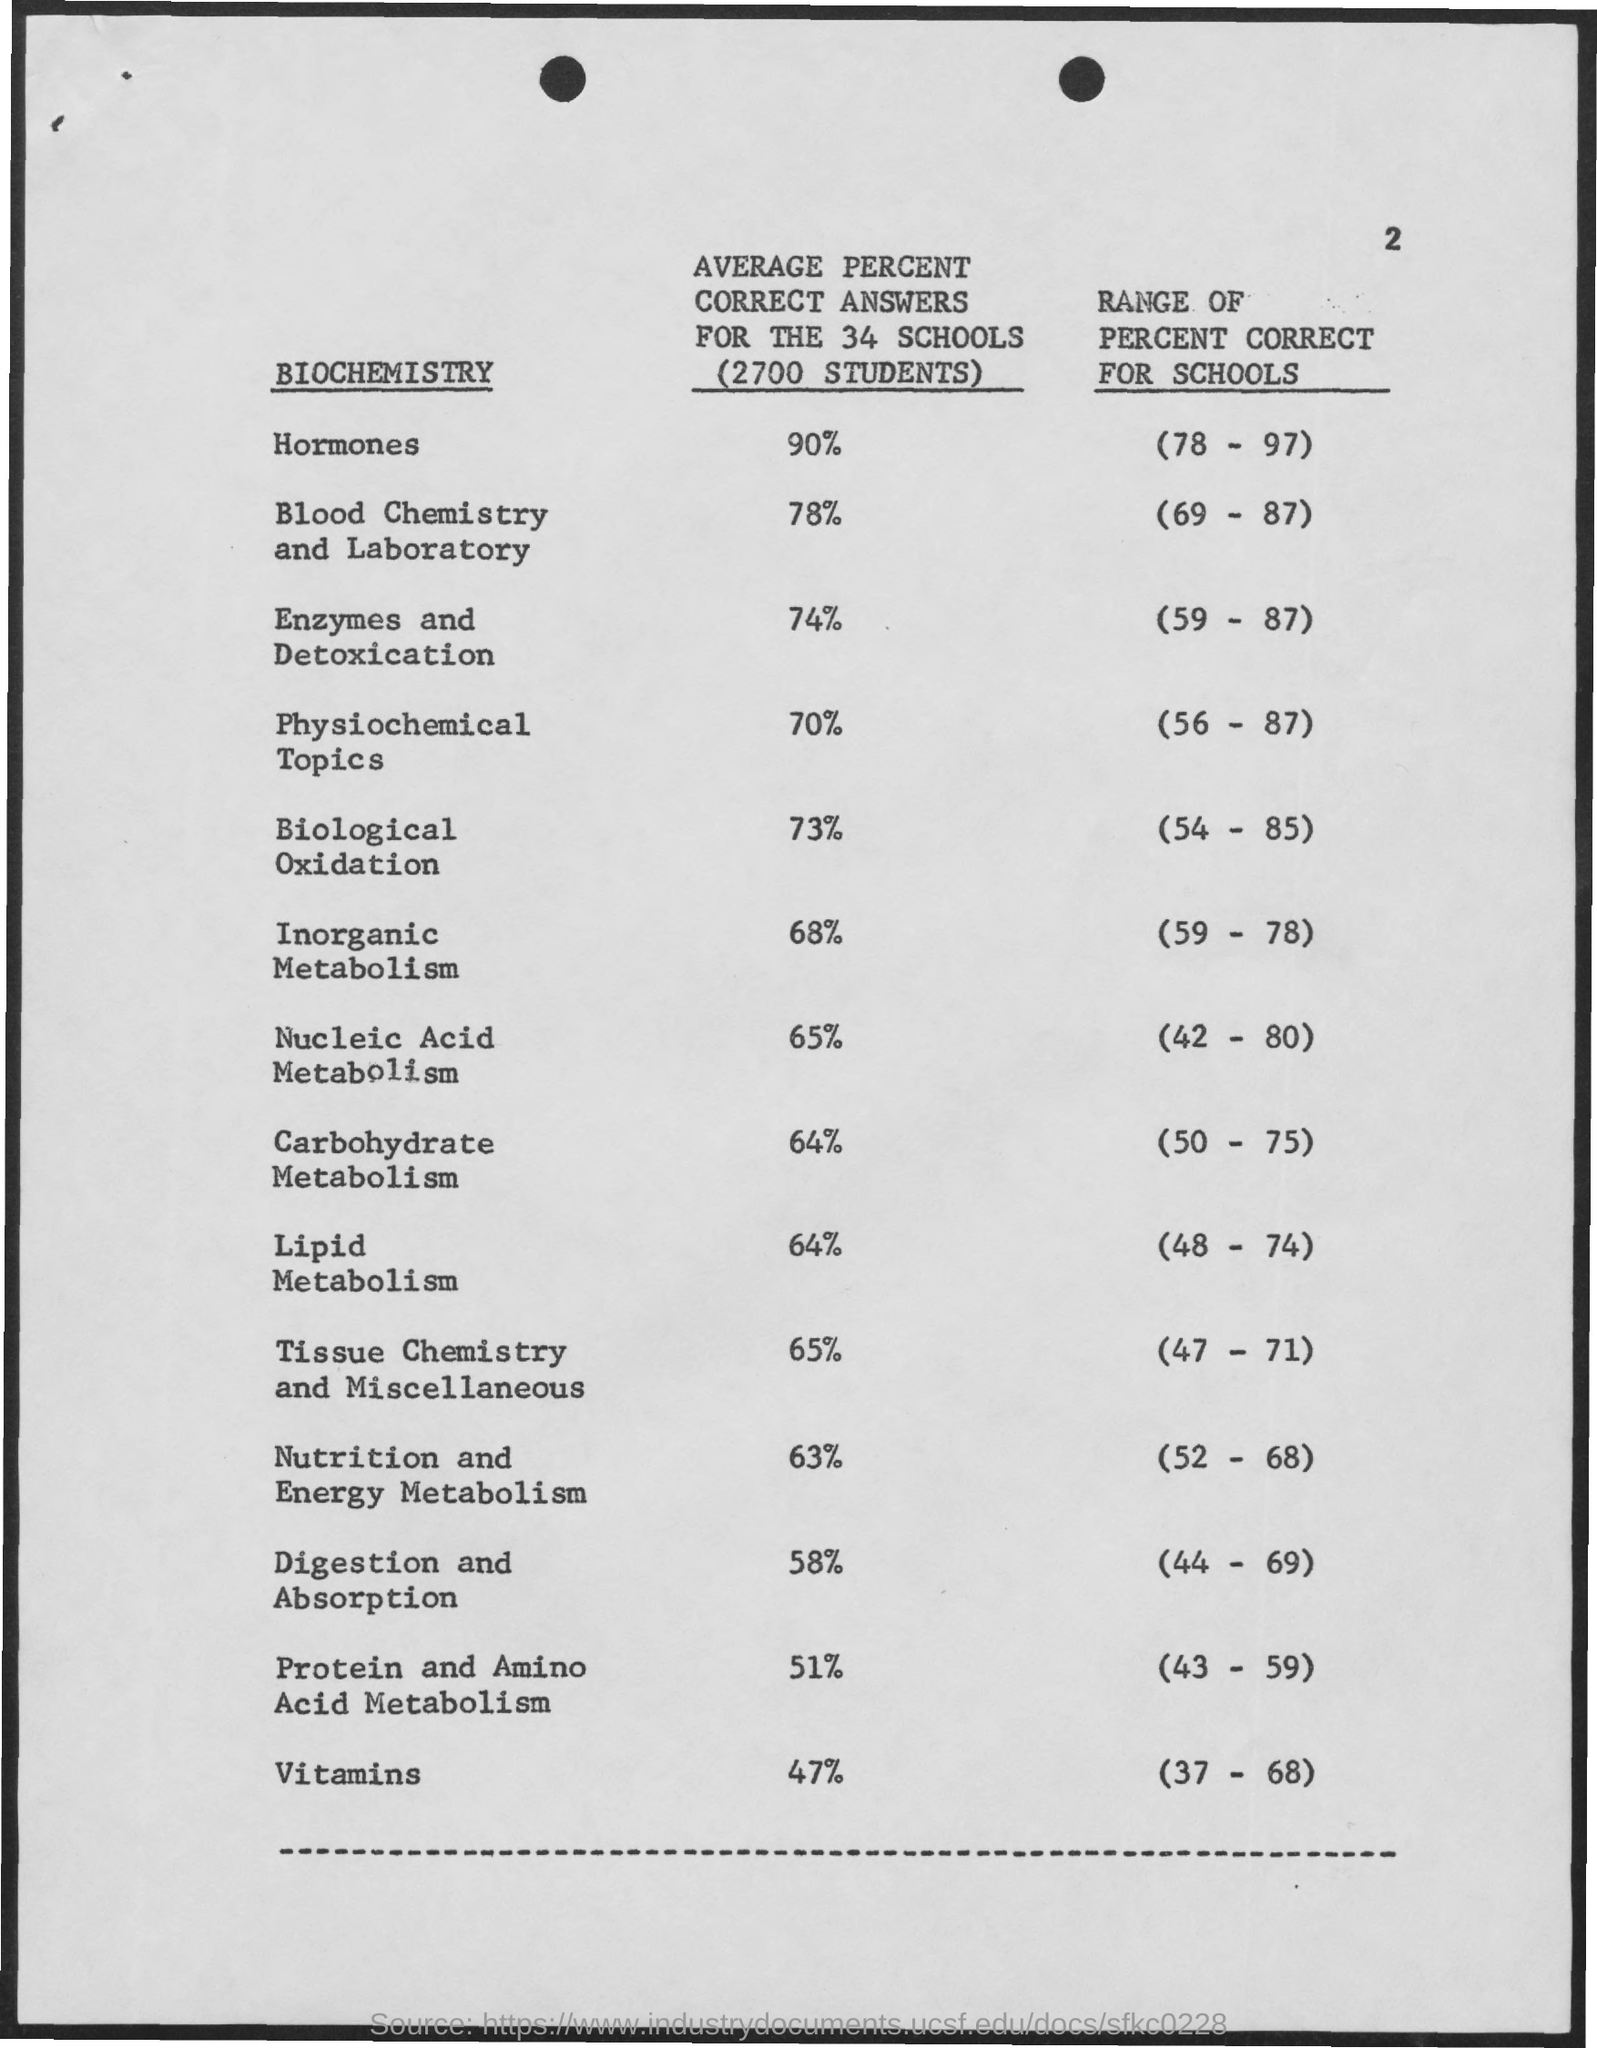How many number of students?
Provide a succinct answer. 2700. 